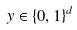<formula> <loc_0><loc_0><loc_500><loc_500>y \in \{ 0 , 1 \} ^ { d }</formula> 